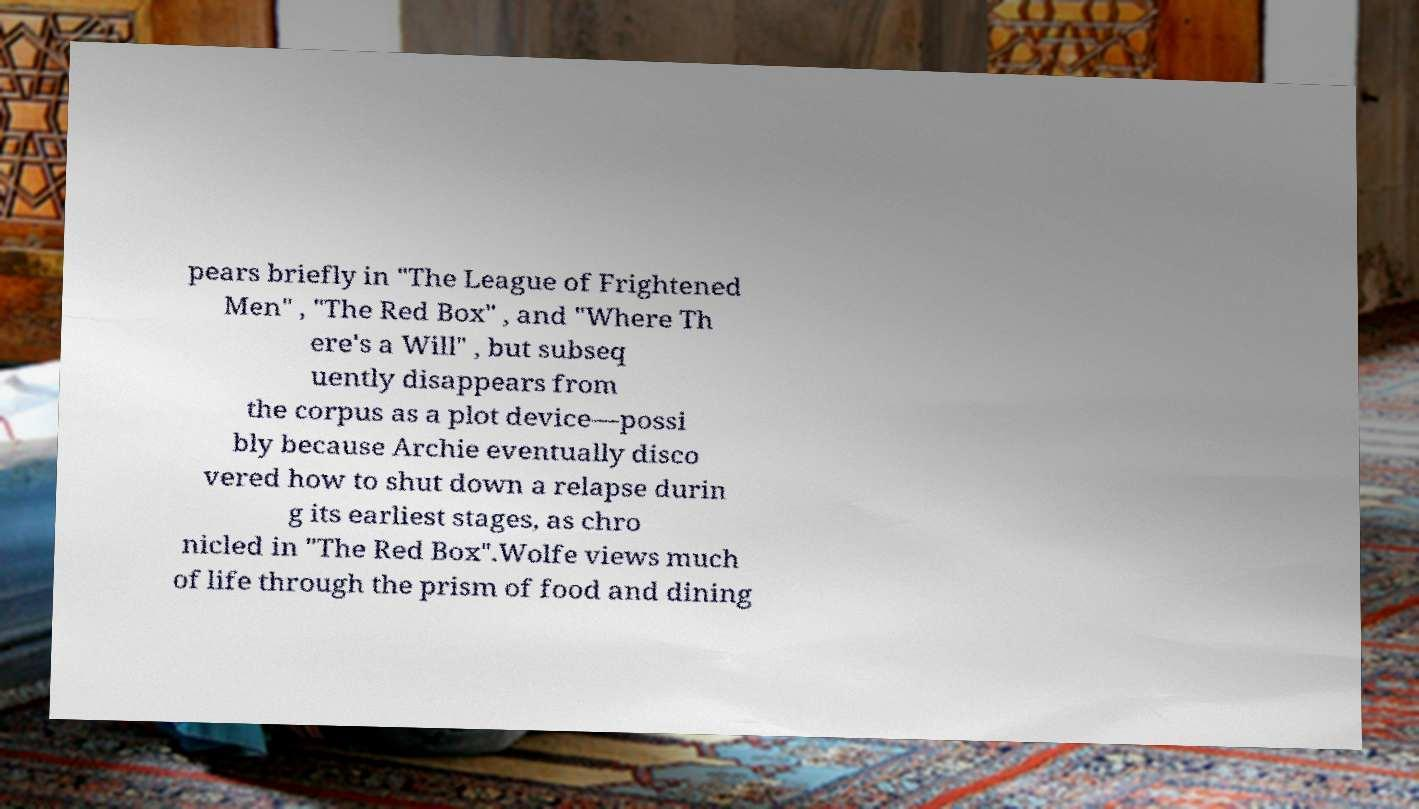For documentation purposes, I need the text within this image transcribed. Could you provide that? pears briefly in "The League of Frightened Men" , "The Red Box" , and "Where Th ere's a Will" , but subseq uently disappears from the corpus as a plot device—possi bly because Archie eventually disco vered how to shut down a relapse durin g its earliest stages, as chro nicled in "The Red Box".Wolfe views much of life through the prism of food and dining 